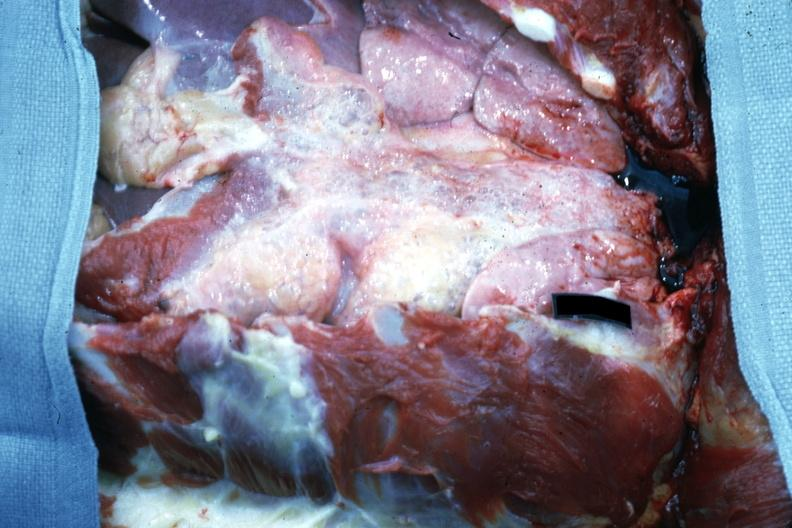where is this?
Answer the question using a single word or phrase. Thorax 